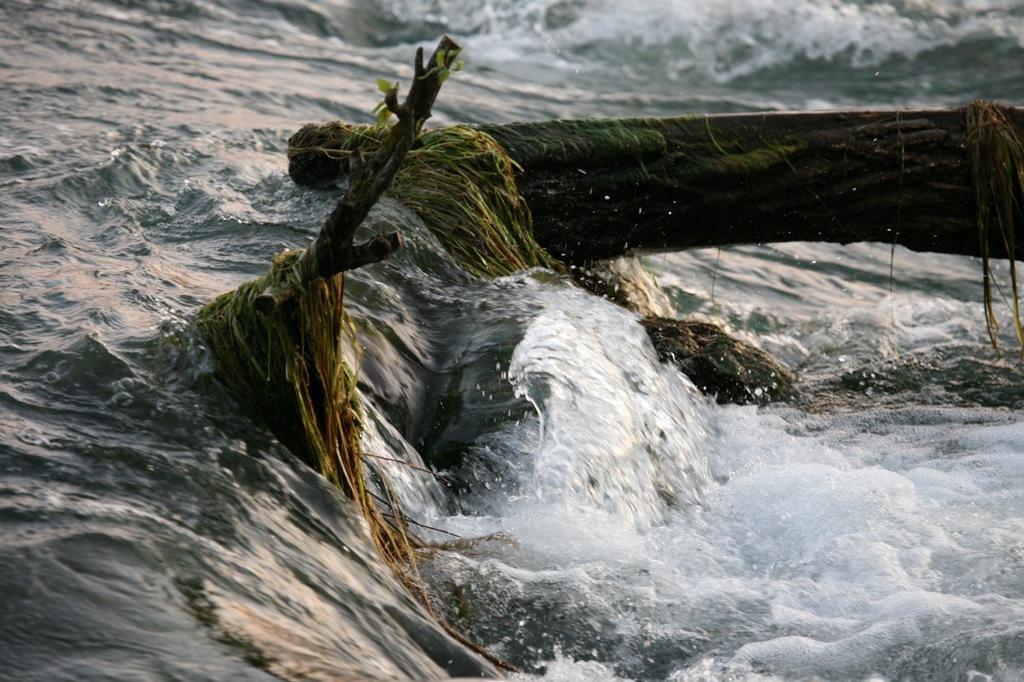In one or two sentences, can you explain what this image depicts? In this picture I can see grass and branches in the water. 